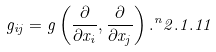Convert formula to latex. <formula><loc_0><loc_0><loc_500><loc_500>g _ { i j } = g \left ( \frac { \partial } { \partial x _ { i } } , \frac { \partial } { \partial x _ { j } } \right ) . ^ { n } { 2 . 1 . 1 1 }</formula> 